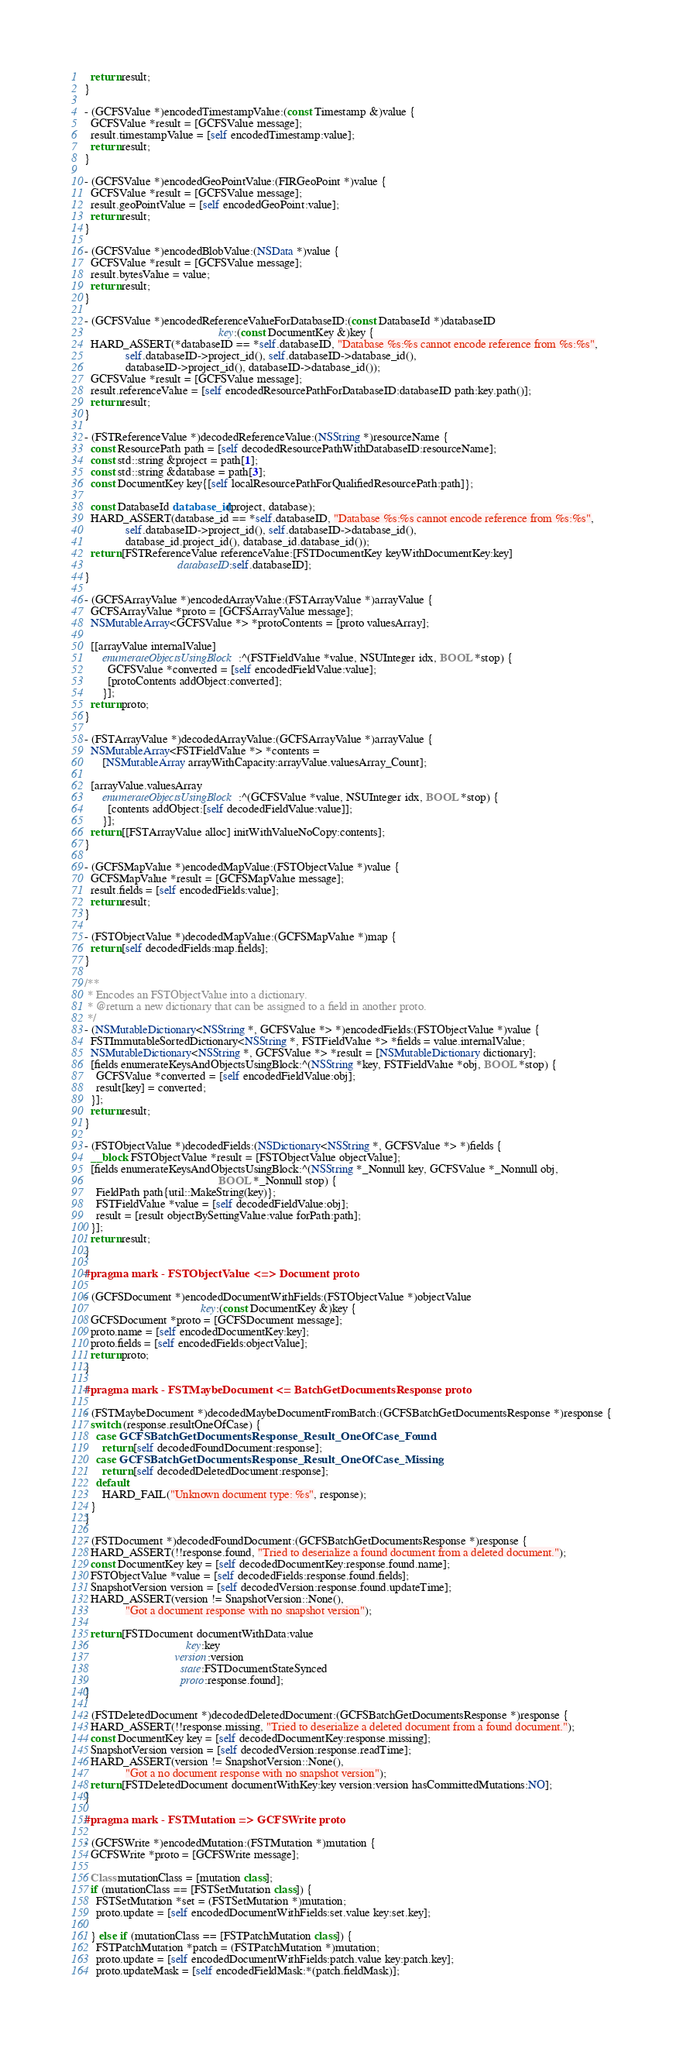<code> <loc_0><loc_0><loc_500><loc_500><_ObjectiveC_>  return result;
}

- (GCFSValue *)encodedTimestampValue:(const Timestamp &)value {
  GCFSValue *result = [GCFSValue message];
  result.timestampValue = [self encodedTimestamp:value];
  return result;
}

- (GCFSValue *)encodedGeoPointValue:(FIRGeoPoint *)value {
  GCFSValue *result = [GCFSValue message];
  result.geoPointValue = [self encodedGeoPoint:value];
  return result;
}

- (GCFSValue *)encodedBlobValue:(NSData *)value {
  GCFSValue *result = [GCFSValue message];
  result.bytesValue = value;
  return result;
}

- (GCFSValue *)encodedReferenceValueForDatabaseID:(const DatabaseId *)databaseID
                                              key:(const DocumentKey &)key {
  HARD_ASSERT(*databaseID == *self.databaseID, "Database %s:%s cannot encode reference from %s:%s",
              self.databaseID->project_id(), self.databaseID->database_id(),
              databaseID->project_id(), databaseID->database_id());
  GCFSValue *result = [GCFSValue message];
  result.referenceValue = [self encodedResourcePathForDatabaseID:databaseID path:key.path()];
  return result;
}

- (FSTReferenceValue *)decodedReferenceValue:(NSString *)resourceName {
  const ResourcePath path = [self decodedResourcePathWithDatabaseID:resourceName];
  const std::string &project = path[1];
  const std::string &database = path[3];
  const DocumentKey key{[self localResourcePathForQualifiedResourcePath:path]};

  const DatabaseId database_id(project, database);
  HARD_ASSERT(database_id == *self.databaseID, "Database %s:%s cannot encode reference from %s:%s",
              self.databaseID->project_id(), self.databaseID->database_id(),
              database_id.project_id(), database_id.database_id());
  return [FSTReferenceValue referenceValue:[FSTDocumentKey keyWithDocumentKey:key]
                                databaseID:self.databaseID];
}

- (GCFSArrayValue *)encodedArrayValue:(FSTArrayValue *)arrayValue {
  GCFSArrayValue *proto = [GCFSArrayValue message];
  NSMutableArray<GCFSValue *> *protoContents = [proto valuesArray];

  [[arrayValue internalValue]
      enumerateObjectsUsingBlock:^(FSTFieldValue *value, NSUInteger idx, BOOL *stop) {
        GCFSValue *converted = [self encodedFieldValue:value];
        [protoContents addObject:converted];
      }];
  return proto;
}

- (FSTArrayValue *)decodedArrayValue:(GCFSArrayValue *)arrayValue {
  NSMutableArray<FSTFieldValue *> *contents =
      [NSMutableArray arrayWithCapacity:arrayValue.valuesArray_Count];

  [arrayValue.valuesArray
      enumerateObjectsUsingBlock:^(GCFSValue *value, NSUInteger idx, BOOL *stop) {
        [contents addObject:[self decodedFieldValue:value]];
      }];
  return [[FSTArrayValue alloc] initWithValueNoCopy:contents];
}

- (GCFSMapValue *)encodedMapValue:(FSTObjectValue *)value {
  GCFSMapValue *result = [GCFSMapValue message];
  result.fields = [self encodedFields:value];
  return result;
}

- (FSTObjectValue *)decodedMapValue:(GCFSMapValue *)map {
  return [self decodedFields:map.fields];
}

/**
 * Encodes an FSTObjectValue into a dictionary.
 * @return a new dictionary that can be assigned to a field in another proto.
 */
- (NSMutableDictionary<NSString *, GCFSValue *> *)encodedFields:(FSTObjectValue *)value {
  FSTImmutableSortedDictionary<NSString *, FSTFieldValue *> *fields = value.internalValue;
  NSMutableDictionary<NSString *, GCFSValue *> *result = [NSMutableDictionary dictionary];
  [fields enumerateKeysAndObjectsUsingBlock:^(NSString *key, FSTFieldValue *obj, BOOL *stop) {
    GCFSValue *converted = [self encodedFieldValue:obj];
    result[key] = converted;
  }];
  return result;
}

- (FSTObjectValue *)decodedFields:(NSDictionary<NSString *, GCFSValue *> *)fields {
  __block FSTObjectValue *result = [FSTObjectValue objectValue];
  [fields enumerateKeysAndObjectsUsingBlock:^(NSString *_Nonnull key, GCFSValue *_Nonnull obj,
                                              BOOL *_Nonnull stop) {
    FieldPath path{util::MakeString(key)};
    FSTFieldValue *value = [self decodedFieldValue:obj];
    result = [result objectBySettingValue:value forPath:path];
  }];
  return result;
}

#pragma mark - FSTObjectValue <=> Document proto

- (GCFSDocument *)encodedDocumentWithFields:(FSTObjectValue *)objectValue
                                        key:(const DocumentKey &)key {
  GCFSDocument *proto = [GCFSDocument message];
  proto.name = [self encodedDocumentKey:key];
  proto.fields = [self encodedFields:objectValue];
  return proto;
}

#pragma mark - FSTMaybeDocument <= BatchGetDocumentsResponse proto

- (FSTMaybeDocument *)decodedMaybeDocumentFromBatch:(GCFSBatchGetDocumentsResponse *)response {
  switch (response.resultOneOfCase) {
    case GCFSBatchGetDocumentsResponse_Result_OneOfCase_Found:
      return [self decodedFoundDocument:response];
    case GCFSBatchGetDocumentsResponse_Result_OneOfCase_Missing:
      return [self decodedDeletedDocument:response];
    default:
      HARD_FAIL("Unknown document type: %s", response);
  }
}

- (FSTDocument *)decodedFoundDocument:(GCFSBatchGetDocumentsResponse *)response {
  HARD_ASSERT(!!response.found, "Tried to deserialize a found document from a deleted document.");
  const DocumentKey key = [self decodedDocumentKey:response.found.name];
  FSTObjectValue *value = [self decodedFields:response.found.fields];
  SnapshotVersion version = [self decodedVersion:response.found.updateTime];
  HARD_ASSERT(version != SnapshotVersion::None(),
              "Got a document response with no snapshot version");

  return [FSTDocument documentWithData:value
                                   key:key
                               version:version
                                 state:FSTDocumentStateSynced
                                 proto:response.found];
}

- (FSTDeletedDocument *)decodedDeletedDocument:(GCFSBatchGetDocumentsResponse *)response {
  HARD_ASSERT(!!response.missing, "Tried to deserialize a deleted document from a found document.");
  const DocumentKey key = [self decodedDocumentKey:response.missing];
  SnapshotVersion version = [self decodedVersion:response.readTime];
  HARD_ASSERT(version != SnapshotVersion::None(),
              "Got a no document response with no snapshot version");
  return [FSTDeletedDocument documentWithKey:key version:version hasCommittedMutations:NO];
}

#pragma mark - FSTMutation => GCFSWrite proto

- (GCFSWrite *)encodedMutation:(FSTMutation *)mutation {
  GCFSWrite *proto = [GCFSWrite message];

  Class mutationClass = [mutation class];
  if (mutationClass == [FSTSetMutation class]) {
    FSTSetMutation *set = (FSTSetMutation *)mutation;
    proto.update = [self encodedDocumentWithFields:set.value key:set.key];

  } else if (mutationClass == [FSTPatchMutation class]) {
    FSTPatchMutation *patch = (FSTPatchMutation *)mutation;
    proto.update = [self encodedDocumentWithFields:patch.value key:patch.key];
    proto.updateMask = [self encodedFieldMask:*(patch.fieldMask)];
</code> 